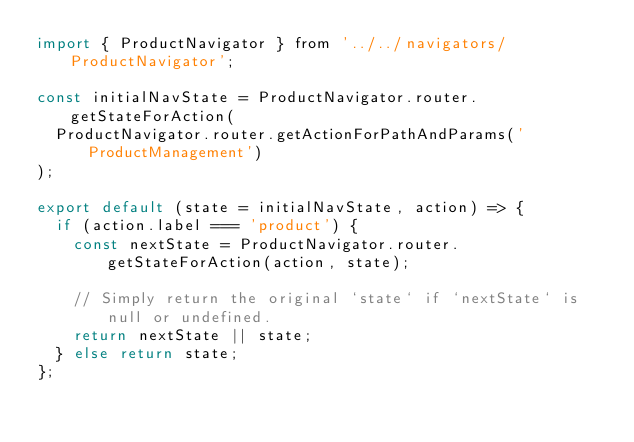Convert code to text. <code><loc_0><loc_0><loc_500><loc_500><_JavaScript_>import { ProductNavigator } from '../../navigators/ProductNavigator';

const initialNavState = ProductNavigator.router.getStateForAction(
  ProductNavigator.router.getActionForPathAndParams('ProductManagement')
);

export default (state = initialNavState, action) => {
  if (action.label === 'product') {
    const nextState = ProductNavigator.router.getStateForAction(action, state);

    // Simply return the original `state` if `nextState` is null or undefined.
    return nextState || state;
  } else return state;
};
</code> 